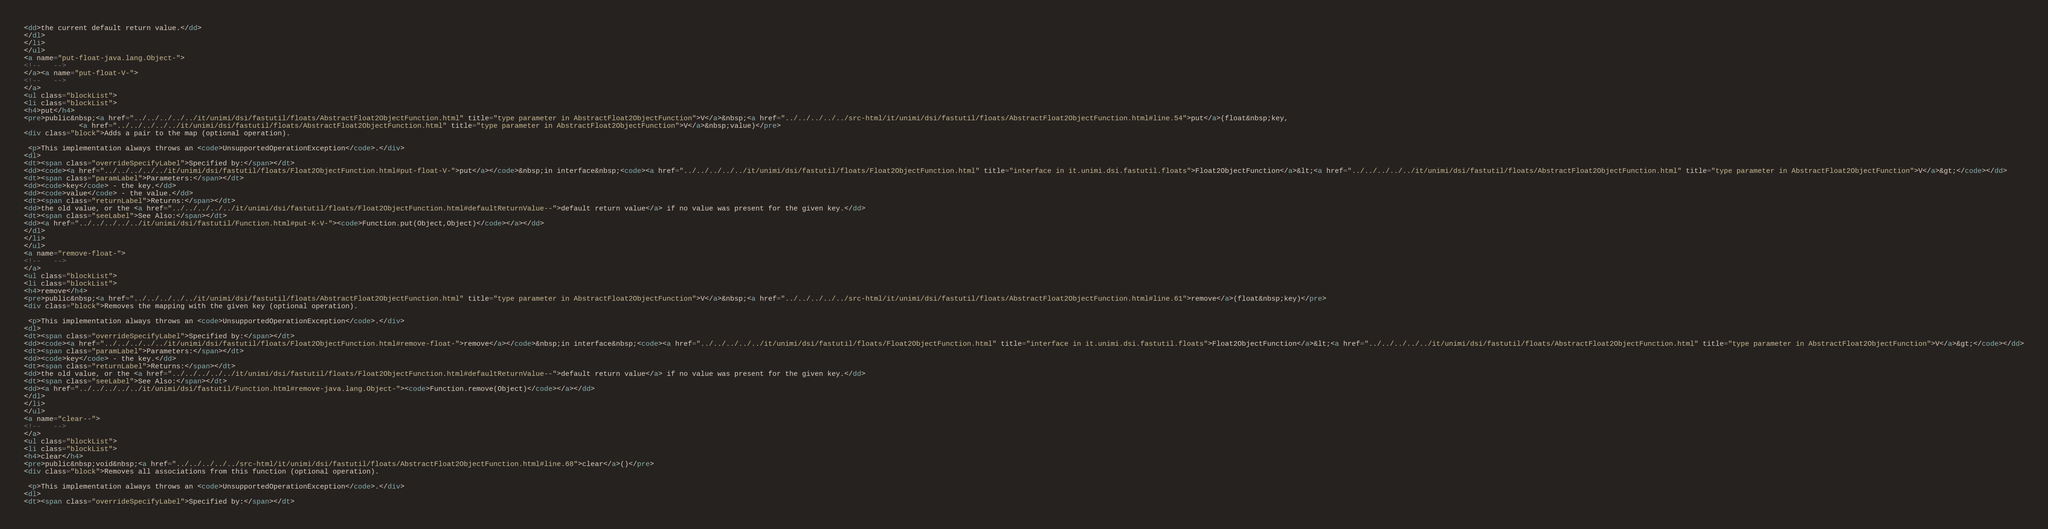Convert code to text. <code><loc_0><loc_0><loc_500><loc_500><_HTML_><dd>the current default return value.</dd>
</dl>
</li>
</ul>
<a name="put-float-java.lang.Object-">
<!--   -->
</a><a name="put-float-V-">
<!--   -->
</a>
<ul class="blockList">
<li class="blockList">
<h4>put</h4>
<pre>public&nbsp;<a href="../../../../../it/unimi/dsi/fastutil/floats/AbstractFloat2ObjectFunction.html" title="type parameter in AbstractFloat2ObjectFunction">V</a>&nbsp;<a href="../../../../../src-html/it/unimi/dsi/fastutil/floats/AbstractFloat2ObjectFunction.html#line.54">put</a>(float&nbsp;key,
             <a href="../../../../../it/unimi/dsi/fastutil/floats/AbstractFloat2ObjectFunction.html" title="type parameter in AbstractFloat2ObjectFunction">V</a>&nbsp;value)</pre>
<div class="block">Adds a pair to the map (optional operation).

 <p>This implementation always throws an <code>UnsupportedOperationException</code>.</div>
<dl>
<dt><span class="overrideSpecifyLabel">Specified by:</span></dt>
<dd><code><a href="../../../../../it/unimi/dsi/fastutil/floats/Float2ObjectFunction.html#put-float-V-">put</a></code>&nbsp;in interface&nbsp;<code><a href="../../../../../it/unimi/dsi/fastutil/floats/Float2ObjectFunction.html" title="interface in it.unimi.dsi.fastutil.floats">Float2ObjectFunction</a>&lt;<a href="../../../../../it/unimi/dsi/fastutil/floats/AbstractFloat2ObjectFunction.html" title="type parameter in AbstractFloat2ObjectFunction">V</a>&gt;</code></dd>
<dt><span class="paramLabel">Parameters:</span></dt>
<dd><code>key</code> - the key.</dd>
<dd><code>value</code> - the value.</dd>
<dt><span class="returnLabel">Returns:</span></dt>
<dd>the old value, or the <a href="../../../../../it/unimi/dsi/fastutil/floats/Float2ObjectFunction.html#defaultReturnValue--">default return value</a> if no value was present for the given key.</dd>
<dt><span class="seeLabel">See Also:</span></dt>
<dd><a href="../../../../../it/unimi/dsi/fastutil/Function.html#put-K-V-"><code>Function.put(Object,Object)</code></a></dd>
</dl>
</li>
</ul>
<a name="remove-float-">
<!--   -->
</a>
<ul class="blockList">
<li class="blockList">
<h4>remove</h4>
<pre>public&nbsp;<a href="../../../../../it/unimi/dsi/fastutil/floats/AbstractFloat2ObjectFunction.html" title="type parameter in AbstractFloat2ObjectFunction">V</a>&nbsp;<a href="../../../../../src-html/it/unimi/dsi/fastutil/floats/AbstractFloat2ObjectFunction.html#line.61">remove</a>(float&nbsp;key)</pre>
<div class="block">Removes the mapping with the given key (optional operation).

 <p>This implementation always throws an <code>UnsupportedOperationException</code>.</div>
<dl>
<dt><span class="overrideSpecifyLabel">Specified by:</span></dt>
<dd><code><a href="../../../../../it/unimi/dsi/fastutil/floats/Float2ObjectFunction.html#remove-float-">remove</a></code>&nbsp;in interface&nbsp;<code><a href="../../../../../it/unimi/dsi/fastutil/floats/Float2ObjectFunction.html" title="interface in it.unimi.dsi.fastutil.floats">Float2ObjectFunction</a>&lt;<a href="../../../../../it/unimi/dsi/fastutil/floats/AbstractFloat2ObjectFunction.html" title="type parameter in AbstractFloat2ObjectFunction">V</a>&gt;</code></dd>
<dt><span class="paramLabel">Parameters:</span></dt>
<dd><code>key</code> - the key.</dd>
<dt><span class="returnLabel">Returns:</span></dt>
<dd>the old value, or the <a href="../../../../../it/unimi/dsi/fastutil/floats/Float2ObjectFunction.html#defaultReturnValue--">default return value</a> if no value was present for the given key.</dd>
<dt><span class="seeLabel">See Also:</span></dt>
<dd><a href="../../../../../it/unimi/dsi/fastutil/Function.html#remove-java.lang.Object-"><code>Function.remove(Object)</code></a></dd>
</dl>
</li>
</ul>
<a name="clear--">
<!--   -->
</a>
<ul class="blockList">
<li class="blockList">
<h4>clear</h4>
<pre>public&nbsp;void&nbsp;<a href="../../../../../src-html/it/unimi/dsi/fastutil/floats/AbstractFloat2ObjectFunction.html#line.68">clear</a>()</pre>
<div class="block">Removes all associations from this function (optional operation).

 <p>This implementation always throws an <code>UnsupportedOperationException</code>.</div>
<dl>
<dt><span class="overrideSpecifyLabel">Specified by:</span></dt></code> 